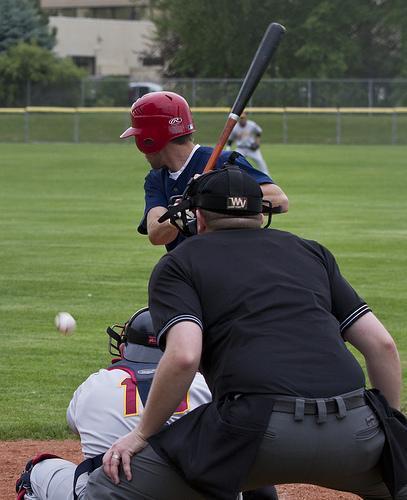How many players?
Give a very brief answer. 4. 